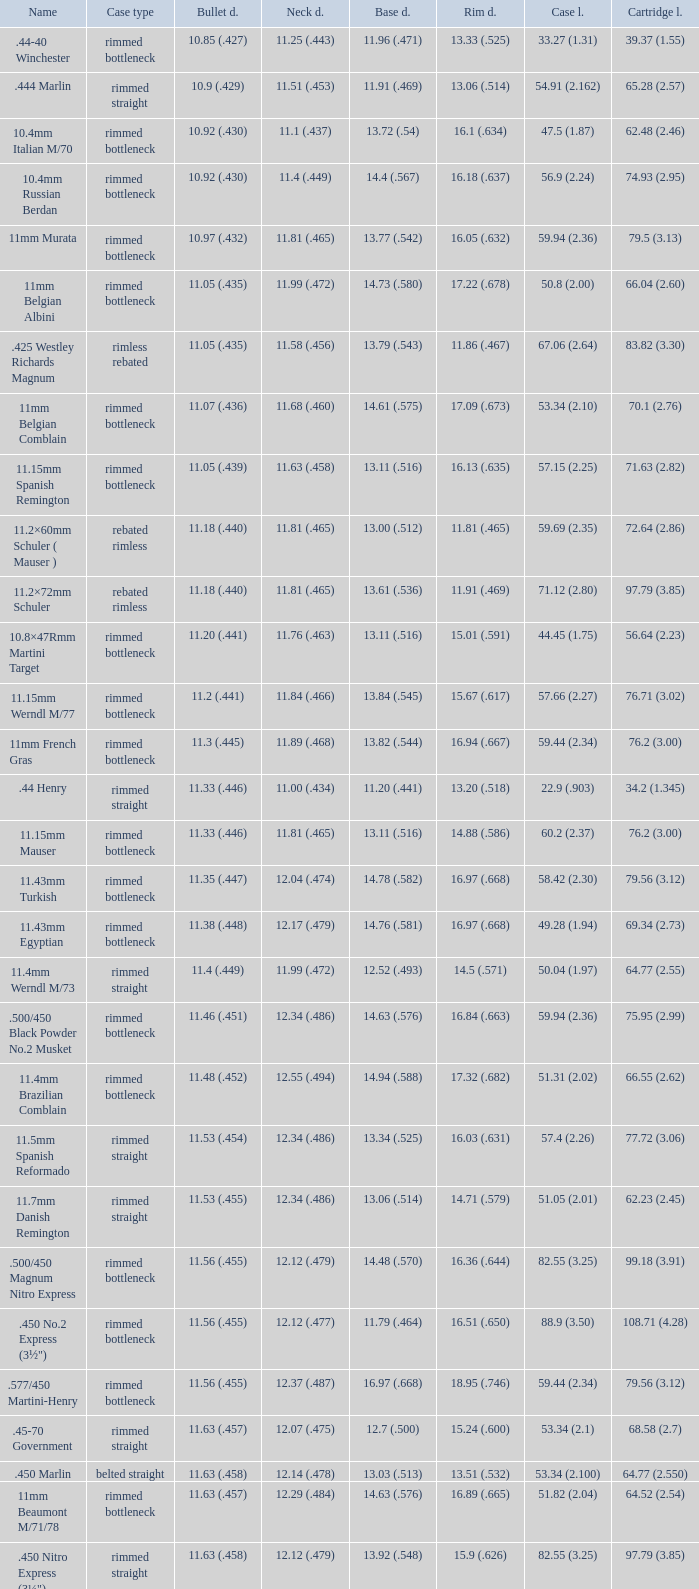Which Bullet diameter has a Name of 11.4mm werndl m/73? 11.4 (.449). 